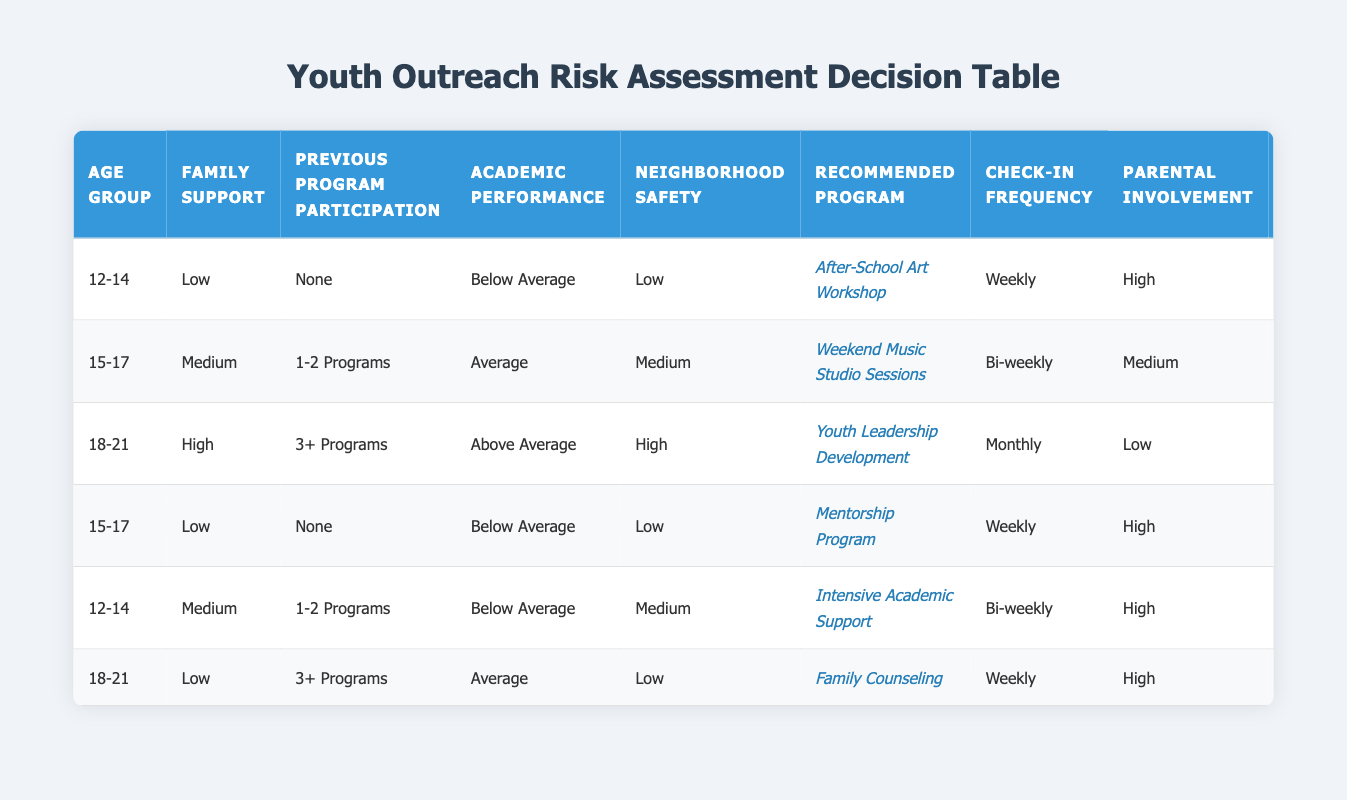What is the recommended program for youth aged 12-14 with low family support, no previous program participation, below average academic performance, and low neighborhood safety? The table shows a specific entry for this combination of conditions. Looking at the first row, the recommended program is the "After-School Art Workshop."
Answer: After-School Art Workshop How often do participants aged 15-17 with medium family support, who have participated in 1-2 programs, average academic performance, and medium neighborhood safety, receive check-ins? By locating the second entry for participants aged 15-17 in the table, we see that the check-in frequency listed is bi-weekly.
Answer: Bi-weekly Are there youth at risk who are recommended for the "Intensive Academic Support" program? By checking the table, we can see that the "Intensive Academic Support" program is recommended for participants aged 12-14 with medium family support, 1-2 programs of previous participation, below average academic performance, and medium neighborhood safety. Therefore, yes, there are youth at risk recommended for this program.
Answer: Yes What is the risk level for the youth aged 18-21 with high family support who have participated in 3 or more programs, with above average academic performance, and high neighborhood safety? The table indicates that for this specific age group and conditions, the risk level is categorized as low. This is found in the third table entry.
Answer: Low How many programs require high parental involvement for youth aged 15-17? The table contains two instances for youth aged 15-17, one with low family support (Mentorship Program), which requires high parental involvement, and the other with medium family support (Weekend Music Studio Sessions) which does not. Thus, there is only one program that requires high parental involvement.
Answer: 1 What is the average risk level for youth aged 12-14 based on the table? There are two entries for youth aged 12-14: one has a high-risk level and the other a medium risk level. To find the average, we assign values: High as 3, Medium as 2. (3 + 2) / 2 = 2.5, which aligns closer to High (3) overall.
Answer: Medium Is there a recommended program for youth aged 18-21 that also requires low parental involvement? From the table, only one entry corresponds to this criteria. The "Youth Leadership Development" program is listed for youth aged 18-21 with high family support. Therefore, the answer is yes, there is a recommended program that fits the description.
Answer: Yes 